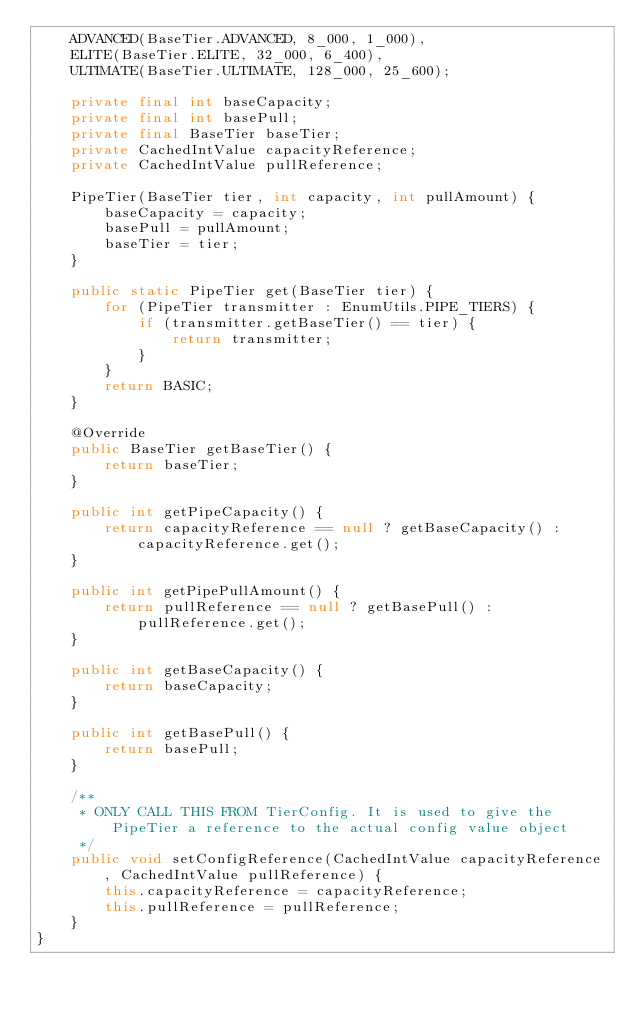Convert code to text. <code><loc_0><loc_0><loc_500><loc_500><_Java_>    ADVANCED(BaseTier.ADVANCED, 8_000, 1_000),
    ELITE(BaseTier.ELITE, 32_000, 6_400),
    ULTIMATE(BaseTier.ULTIMATE, 128_000, 25_600);

    private final int baseCapacity;
    private final int basePull;
    private final BaseTier baseTier;
    private CachedIntValue capacityReference;
    private CachedIntValue pullReference;

    PipeTier(BaseTier tier, int capacity, int pullAmount) {
        baseCapacity = capacity;
        basePull = pullAmount;
        baseTier = tier;
    }

    public static PipeTier get(BaseTier tier) {
        for (PipeTier transmitter : EnumUtils.PIPE_TIERS) {
            if (transmitter.getBaseTier() == tier) {
                return transmitter;
            }
        }
        return BASIC;
    }

    @Override
    public BaseTier getBaseTier() {
        return baseTier;
    }

    public int getPipeCapacity() {
        return capacityReference == null ? getBaseCapacity() : capacityReference.get();
    }

    public int getPipePullAmount() {
        return pullReference == null ? getBasePull() : pullReference.get();
    }

    public int getBaseCapacity() {
        return baseCapacity;
    }

    public int getBasePull() {
        return basePull;
    }

    /**
     * ONLY CALL THIS FROM TierConfig. It is used to give the PipeTier a reference to the actual config value object
     */
    public void setConfigReference(CachedIntValue capacityReference, CachedIntValue pullReference) {
        this.capacityReference = capacityReference;
        this.pullReference = pullReference;
    }
}</code> 